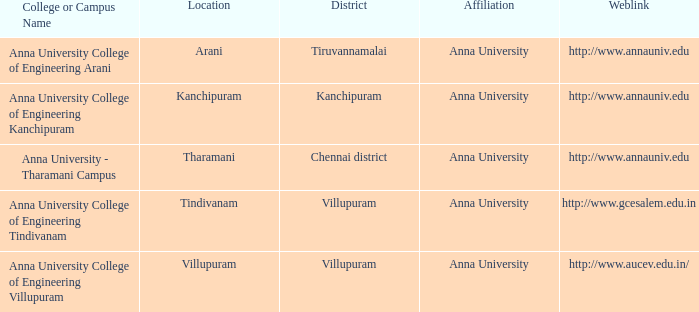What Location has a College or Campus Name of anna university - tharamani campus? Tharamani. 